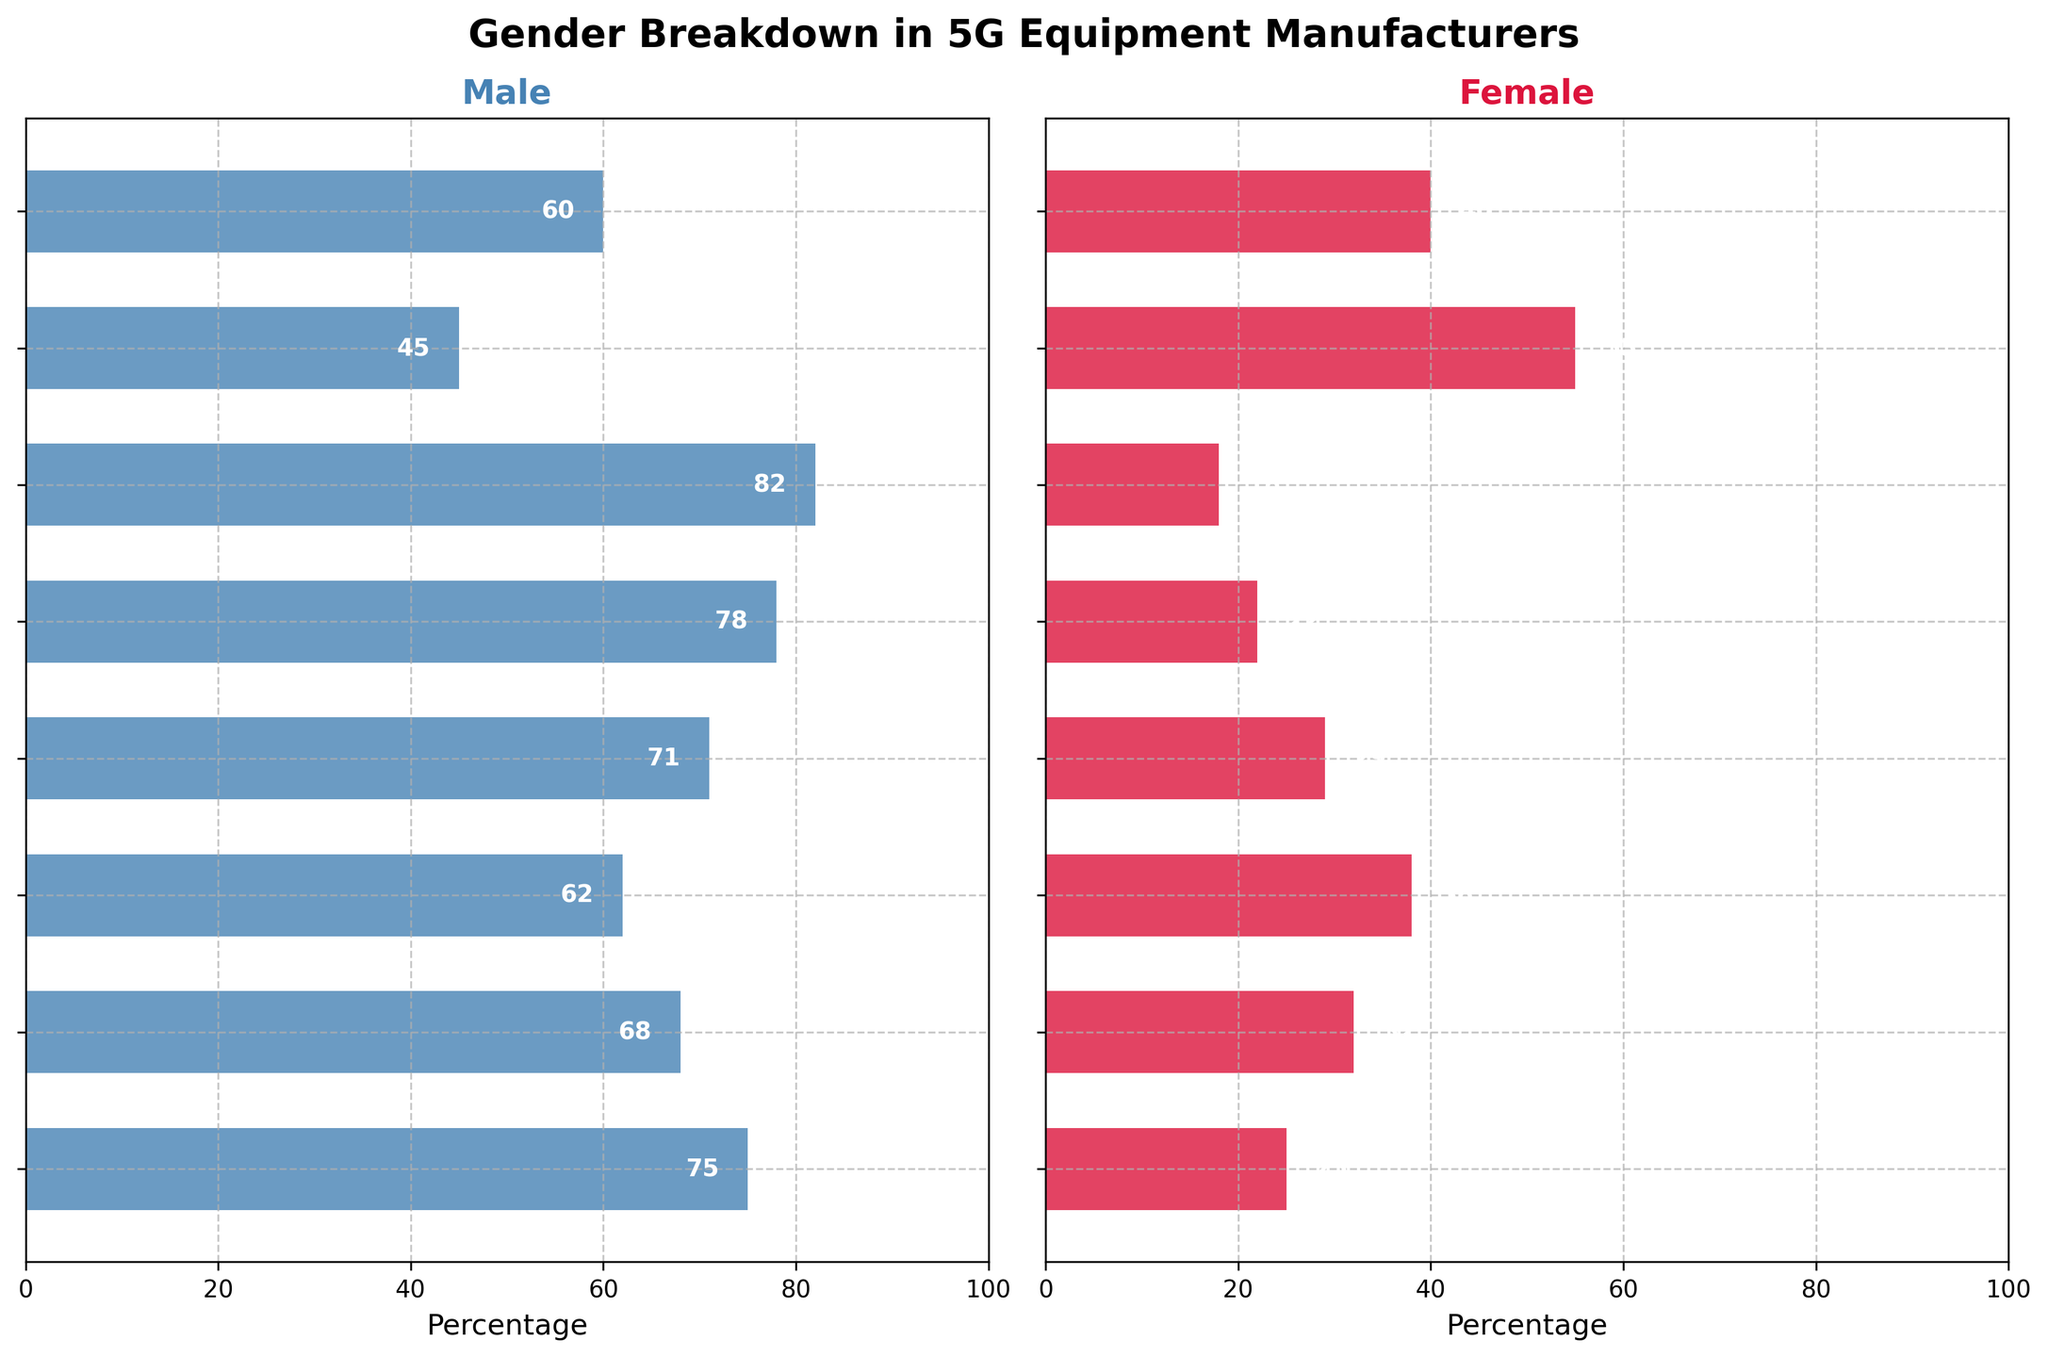What's the title of the figure? The title is located at the top of the figure, and it states the general topic or subject of the plot.
Answer: Gender Breakdown in 5G Equipment Manufacturers Which job level has the highest percentage of male employees? Looking at the left side of the figure, the bar furthest to the right (largest value) represents the job level with the highest percentage of males.
Answer: Technicians Which job level has a higher percentage of female employees compared to male employees? On the right side of the figure, find the job level where the red bar is longer than the blue bar, indicating a higher percentage of females.
Answer: Administrative What is the percentage difference between male and female Engineers? Find the values for both male and female Engineers (78% and 22%, respectively), then calculate the difference (78% - 22%).
Answer: 56% Which job levels have at least 30% female employees? Look at the right side of the figure and identify bars that have a percentage (length) of 30 or more. The relevant job levels are Administrative, Middle Management, Senior Management, and Entry Level.
Answer: Administrative, Middle Management, Senior Management, Entry Level How does the percentage of male employees in Technical Specialists compare to that in Engineers? Compare the lengths of the male bars for Technical Specialists and Engineers (71% and 78%, respectively). Engineers have a higher percentage.
Answer: Engineers have a higher percentage Which job level has the lowest percentage of female employees? On the right side of the figure, find the shortest red bar indicating the lowest percentage of females.
Answer: Technicians In which job levels do women constitute exactly 25% or 40%? Look at the right side of the figure and identify the job levels where the red bars show exactly 25% and 40%. For 25%, it's Executive, and for 40%, it's Entry Level.
Answer: Executive (25%), Entry Level (40%) What's the combined percentage of male and female employees in Executive roles? Sum the percentages of male and female employees in the Executive category (75% + 25%).
Answer: 100% Which middle-management level is closer to gender parity? Compare the male and female percentages in Middle Management and Senior Management. Middle Management is 62% male, 38% female. Senior Management is 68% male, 32% female. Middle Management is closer to 50/50.
Answer: Middle Management 